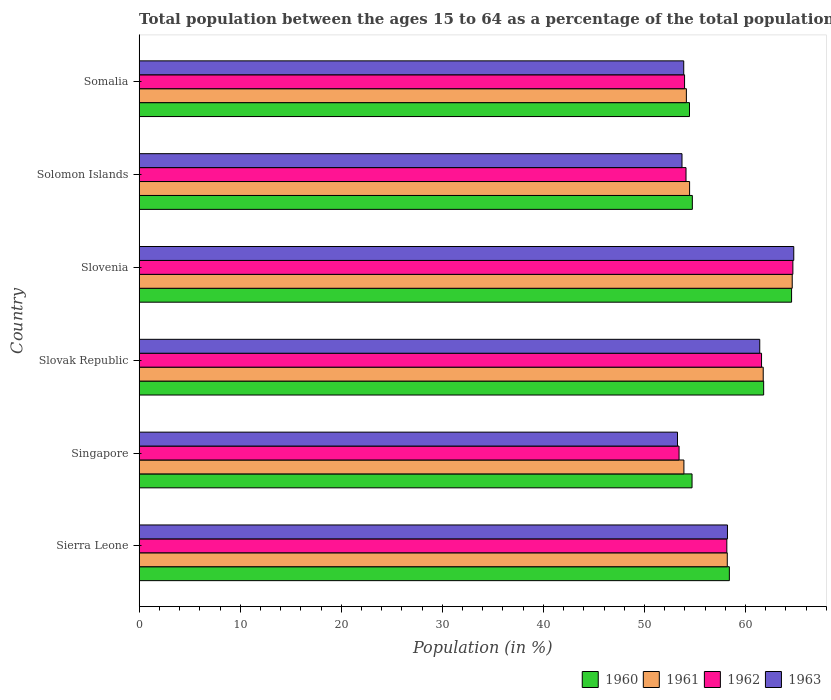How many different coloured bars are there?
Ensure brevity in your answer.  4. How many groups of bars are there?
Your answer should be very brief. 6. How many bars are there on the 4th tick from the top?
Your response must be concise. 4. What is the label of the 2nd group of bars from the top?
Make the answer very short. Solomon Islands. What is the percentage of the population ages 15 to 64 in 1960 in Sierra Leone?
Your answer should be very brief. 58.4. Across all countries, what is the maximum percentage of the population ages 15 to 64 in 1961?
Give a very brief answer. 64.62. Across all countries, what is the minimum percentage of the population ages 15 to 64 in 1960?
Your answer should be compact. 54.46. In which country was the percentage of the population ages 15 to 64 in 1961 maximum?
Offer a terse response. Slovenia. In which country was the percentage of the population ages 15 to 64 in 1960 minimum?
Your answer should be compact. Somalia. What is the total percentage of the population ages 15 to 64 in 1961 in the graph?
Ensure brevity in your answer.  347.1. What is the difference between the percentage of the population ages 15 to 64 in 1963 in Slovak Republic and that in Solomon Islands?
Your answer should be compact. 7.69. What is the difference between the percentage of the population ages 15 to 64 in 1960 in Slovenia and the percentage of the population ages 15 to 64 in 1962 in Singapore?
Make the answer very short. 11.14. What is the average percentage of the population ages 15 to 64 in 1963 per country?
Offer a terse response. 57.55. What is the difference between the percentage of the population ages 15 to 64 in 1960 and percentage of the population ages 15 to 64 in 1962 in Sierra Leone?
Your response must be concise. 0.25. In how many countries, is the percentage of the population ages 15 to 64 in 1962 greater than 58 ?
Your answer should be compact. 3. What is the ratio of the percentage of the population ages 15 to 64 in 1960 in Slovenia to that in Somalia?
Give a very brief answer. 1.19. What is the difference between the highest and the second highest percentage of the population ages 15 to 64 in 1960?
Provide a short and direct response. 2.76. What is the difference between the highest and the lowest percentage of the population ages 15 to 64 in 1960?
Your response must be concise. 10.1. What does the 2nd bar from the top in Slovenia represents?
Ensure brevity in your answer.  1962. Is it the case that in every country, the sum of the percentage of the population ages 15 to 64 in 1963 and percentage of the population ages 15 to 64 in 1961 is greater than the percentage of the population ages 15 to 64 in 1960?
Your response must be concise. Yes. Are all the bars in the graph horizontal?
Ensure brevity in your answer.  Yes. How many countries are there in the graph?
Keep it short and to the point. 6. Are the values on the major ticks of X-axis written in scientific E-notation?
Your answer should be very brief. No. Does the graph contain any zero values?
Make the answer very short. No. Does the graph contain grids?
Offer a very short reply. No. How many legend labels are there?
Ensure brevity in your answer.  4. How are the legend labels stacked?
Ensure brevity in your answer.  Horizontal. What is the title of the graph?
Make the answer very short. Total population between the ages 15 to 64 as a percentage of the total population. What is the label or title of the Y-axis?
Give a very brief answer. Country. What is the Population (in %) in 1960 in Sierra Leone?
Ensure brevity in your answer.  58.4. What is the Population (in %) in 1961 in Sierra Leone?
Offer a very short reply. 58.2. What is the Population (in %) of 1962 in Sierra Leone?
Give a very brief answer. 58.15. What is the Population (in %) of 1963 in Sierra Leone?
Your response must be concise. 58.21. What is the Population (in %) in 1960 in Singapore?
Provide a short and direct response. 54.71. What is the Population (in %) in 1961 in Singapore?
Your response must be concise. 53.91. What is the Population (in %) in 1962 in Singapore?
Your response must be concise. 53.42. What is the Population (in %) in 1963 in Singapore?
Provide a short and direct response. 53.27. What is the Population (in %) in 1960 in Slovak Republic?
Your response must be concise. 61.8. What is the Population (in %) in 1961 in Slovak Republic?
Ensure brevity in your answer.  61.75. What is the Population (in %) in 1962 in Slovak Republic?
Keep it short and to the point. 61.59. What is the Population (in %) of 1963 in Slovak Republic?
Give a very brief answer. 61.41. What is the Population (in %) in 1960 in Slovenia?
Your answer should be very brief. 64.56. What is the Population (in %) in 1961 in Slovenia?
Provide a succinct answer. 64.62. What is the Population (in %) in 1962 in Slovenia?
Ensure brevity in your answer.  64.69. What is the Population (in %) in 1963 in Slovenia?
Your answer should be compact. 64.78. What is the Population (in %) of 1960 in Solomon Islands?
Ensure brevity in your answer.  54.74. What is the Population (in %) of 1961 in Solomon Islands?
Keep it short and to the point. 54.47. What is the Population (in %) in 1962 in Solomon Islands?
Your response must be concise. 54.11. What is the Population (in %) in 1963 in Solomon Islands?
Your answer should be very brief. 53.72. What is the Population (in %) in 1960 in Somalia?
Your response must be concise. 54.46. What is the Population (in %) of 1961 in Somalia?
Provide a succinct answer. 54.15. What is the Population (in %) of 1962 in Somalia?
Give a very brief answer. 53.97. What is the Population (in %) in 1963 in Somalia?
Provide a short and direct response. 53.89. Across all countries, what is the maximum Population (in %) of 1960?
Offer a terse response. 64.56. Across all countries, what is the maximum Population (in %) in 1961?
Make the answer very short. 64.62. Across all countries, what is the maximum Population (in %) of 1962?
Offer a very short reply. 64.69. Across all countries, what is the maximum Population (in %) of 1963?
Offer a very short reply. 64.78. Across all countries, what is the minimum Population (in %) of 1960?
Provide a short and direct response. 54.46. Across all countries, what is the minimum Population (in %) in 1961?
Keep it short and to the point. 53.91. Across all countries, what is the minimum Population (in %) of 1962?
Keep it short and to the point. 53.42. Across all countries, what is the minimum Population (in %) of 1963?
Offer a terse response. 53.27. What is the total Population (in %) of 1960 in the graph?
Offer a terse response. 348.67. What is the total Population (in %) of 1961 in the graph?
Your answer should be compact. 347.1. What is the total Population (in %) of 1962 in the graph?
Your answer should be very brief. 345.94. What is the total Population (in %) in 1963 in the graph?
Provide a short and direct response. 345.28. What is the difference between the Population (in %) of 1960 in Sierra Leone and that in Singapore?
Offer a very short reply. 3.69. What is the difference between the Population (in %) of 1961 in Sierra Leone and that in Singapore?
Provide a succinct answer. 4.29. What is the difference between the Population (in %) of 1962 in Sierra Leone and that in Singapore?
Make the answer very short. 4.73. What is the difference between the Population (in %) of 1963 in Sierra Leone and that in Singapore?
Your response must be concise. 4.94. What is the difference between the Population (in %) of 1960 in Sierra Leone and that in Slovak Republic?
Give a very brief answer. -3.39. What is the difference between the Population (in %) in 1961 in Sierra Leone and that in Slovak Republic?
Offer a terse response. -3.56. What is the difference between the Population (in %) in 1962 in Sierra Leone and that in Slovak Republic?
Make the answer very short. -3.44. What is the difference between the Population (in %) in 1963 in Sierra Leone and that in Slovak Republic?
Offer a terse response. -3.19. What is the difference between the Population (in %) of 1960 in Sierra Leone and that in Slovenia?
Ensure brevity in your answer.  -6.16. What is the difference between the Population (in %) of 1961 in Sierra Leone and that in Slovenia?
Offer a terse response. -6.43. What is the difference between the Population (in %) of 1962 in Sierra Leone and that in Slovenia?
Give a very brief answer. -6.54. What is the difference between the Population (in %) of 1963 in Sierra Leone and that in Slovenia?
Keep it short and to the point. -6.56. What is the difference between the Population (in %) of 1960 in Sierra Leone and that in Solomon Islands?
Give a very brief answer. 3.66. What is the difference between the Population (in %) in 1961 in Sierra Leone and that in Solomon Islands?
Give a very brief answer. 3.73. What is the difference between the Population (in %) in 1962 in Sierra Leone and that in Solomon Islands?
Keep it short and to the point. 4.04. What is the difference between the Population (in %) in 1963 in Sierra Leone and that in Solomon Islands?
Your answer should be compact. 4.5. What is the difference between the Population (in %) in 1960 in Sierra Leone and that in Somalia?
Your answer should be very brief. 3.95. What is the difference between the Population (in %) of 1961 in Sierra Leone and that in Somalia?
Ensure brevity in your answer.  4.05. What is the difference between the Population (in %) of 1962 in Sierra Leone and that in Somalia?
Your answer should be very brief. 4.18. What is the difference between the Population (in %) of 1963 in Sierra Leone and that in Somalia?
Keep it short and to the point. 4.33. What is the difference between the Population (in %) in 1960 in Singapore and that in Slovak Republic?
Provide a short and direct response. -7.09. What is the difference between the Population (in %) of 1961 in Singapore and that in Slovak Republic?
Make the answer very short. -7.85. What is the difference between the Population (in %) of 1962 in Singapore and that in Slovak Republic?
Make the answer very short. -8.16. What is the difference between the Population (in %) of 1963 in Singapore and that in Slovak Republic?
Your answer should be compact. -8.14. What is the difference between the Population (in %) in 1960 in Singapore and that in Slovenia?
Provide a succinct answer. -9.85. What is the difference between the Population (in %) of 1961 in Singapore and that in Slovenia?
Ensure brevity in your answer.  -10.72. What is the difference between the Population (in %) of 1962 in Singapore and that in Slovenia?
Ensure brevity in your answer.  -11.26. What is the difference between the Population (in %) of 1963 in Singapore and that in Slovenia?
Give a very brief answer. -11.5. What is the difference between the Population (in %) of 1960 in Singapore and that in Solomon Islands?
Provide a short and direct response. -0.03. What is the difference between the Population (in %) of 1961 in Singapore and that in Solomon Islands?
Make the answer very short. -0.56. What is the difference between the Population (in %) in 1962 in Singapore and that in Solomon Islands?
Provide a succinct answer. -0.69. What is the difference between the Population (in %) of 1963 in Singapore and that in Solomon Islands?
Offer a terse response. -0.45. What is the difference between the Population (in %) of 1960 in Singapore and that in Somalia?
Provide a succinct answer. 0.25. What is the difference between the Population (in %) in 1961 in Singapore and that in Somalia?
Offer a very short reply. -0.24. What is the difference between the Population (in %) in 1962 in Singapore and that in Somalia?
Your answer should be compact. -0.54. What is the difference between the Population (in %) in 1963 in Singapore and that in Somalia?
Your answer should be compact. -0.62. What is the difference between the Population (in %) in 1960 in Slovak Republic and that in Slovenia?
Ensure brevity in your answer.  -2.76. What is the difference between the Population (in %) of 1961 in Slovak Republic and that in Slovenia?
Make the answer very short. -2.87. What is the difference between the Population (in %) in 1962 in Slovak Republic and that in Slovenia?
Provide a short and direct response. -3.1. What is the difference between the Population (in %) in 1963 in Slovak Republic and that in Slovenia?
Give a very brief answer. -3.37. What is the difference between the Population (in %) in 1960 in Slovak Republic and that in Solomon Islands?
Offer a terse response. 7.06. What is the difference between the Population (in %) of 1961 in Slovak Republic and that in Solomon Islands?
Your response must be concise. 7.29. What is the difference between the Population (in %) in 1962 in Slovak Republic and that in Solomon Islands?
Provide a succinct answer. 7.47. What is the difference between the Population (in %) of 1963 in Slovak Republic and that in Solomon Islands?
Provide a short and direct response. 7.69. What is the difference between the Population (in %) of 1960 in Slovak Republic and that in Somalia?
Make the answer very short. 7.34. What is the difference between the Population (in %) of 1961 in Slovak Republic and that in Somalia?
Your response must be concise. 7.6. What is the difference between the Population (in %) in 1962 in Slovak Republic and that in Somalia?
Your answer should be compact. 7.62. What is the difference between the Population (in %) of 1963 in Slovak Republic and that in Somalia?
Ensure brevity in your answer.  7.52. What is the difference between the Population (in %) of 1960 in Slovenia and that in Solomon Islands?
Provide a short and direct response. 9.82. What is the difference between the Population (in %) of 1961 in Slovenia and that in Solomon Islands?
Provide a short and direct response. 10.16. What is the difference between the Population (in %) of 1962 in Slovenia and that in Solomon Islands?
Keep it short and to the point. 10.57. What is the difference between the Population (in %) of 1963 in Slovenia and that in Solomon Islands?
Offer a terse response. 11.06. What is the difference between the Population (in %) of 1960 in Slovenia and that in Somalia?
Your answer should be compact. 10.1. What is the difference between the Population (in %) in 1961 in Slovenia and that in Somalia?
Keep it short and to the point. 10.47. What is the difference between the Population (in %) in 1962 in Slovenia and that in Somalia?
Ensure brevity in your answer.  10.72. What is the difference between the Population (in %) of 1963 in Slovenia and that in Somalia?
Your answer should be compact. 10.89. What is the difference between the Population (in %) of 1960 in Solomon Islands and that in Somalia?
Provide a succinct answer. 0.28. What is the difference between the Population (in %) in 1961 in Solomon Islands and that in Somalia?
Provide a succinct answer. 0.32. What is the difference between the Population (in %) in 1962 in Solomon Islands and that in Somalia?
Ensure brevity in your answer.  0.14. What is the difference between the Population (in %) in 1963 in Solomon Islands and that in Somalia?
Offer a very short reply. -0.17. What is the difference between the Population (in %) in 1960 in Sierra Leone and the Population (in %) in 1961 in Singapore?
Keep it short and to the point. 4.5. What is the difference between the Population (in %) of 1960 in Sierra Leone and the Population (in %) of 1962 in Singapore?
Offer a terse response. 4.98. What is the difference between the Population (in %) in 1960 in Sierra Leone and the Population (in %) in 1963 in Singapore?
Offer a terse response. 5.13. What is the difference between the Population (in %) in 1961 in Sierra Leone and the Population (in %) in 1962 in Singapore?
Ensure brevity in your answer.  4.77. What is the difference between the Population (in %) in 1961 in Sierra Leone and the Population (in %) in 1963 in Singapore?
Your response must be concise. 4.93. What is the difference between the Population (in %) of 1962 in Sierra Leone and the Population (in %) of 1963 in Singapore?
Offer a very short reply. 4.88. What is the difference between the Population (in %) of 1960 in Sierra Leone and the Population (in %) of 1961 in Slovak Republic?
Give a very brief answer. -3.35. What is the difference between the Population (in %) in 1960 in Sierra Leone and the Population (in %) in 1962 in Slovak Republic?
Your response must be concise. -3.18. What is the difference between the Population (in %) of 1960 in Sierra Leone and the Population (in %) of 1963 in Slovak Republic?
Offer a terse response. -3.01. What is the difference between the Population (in %) in 1961 in Sierra Leone and the Population (in %) in 1962 in Slovak Republic?
Provide a succinct answer. -3.39. What is the difference between the Population (in %) in 1961 in Sierra Leone and the Population (in %) in 1963 in Slovak Republic?
Your response must be concise. -3.21. What is the difference between the Population (in %) in 1962 in Sierra Leone and the Population (in %) in 1963 in Slovak Republic?
Give a very brief answer. -3.26. What is the difference between the Population (in %) in 1960 in Sierra Leone and the Population (in %) in 1961 in Slovenia?
Keep it short and to the point. -6.22. What is the difference between the Population (in %) in 1960 in Sierra Leone and the Population (in %) in 1962 in Slovenia?
Your answer should be very brief. -6.29. What is the difference between the Population (in %) of 1960 in Sierra Leone and the Population (in %) of 1963 in Slovenia?
Make the answer very short. -6.37. What is the difference between the Population (in %) in 1961 in Sierra Leone and the Population (in %) in 1962 in Slovenia?
Offer a terse response. -6.49. What is the difference between the Population (in %) in 1961 in Sierra Leone and the Population (in %) in 1963 in Slovenia?
Your response must be concise. -6.58. What is the difference between the Population (in %) in 1962 in Sierra Leone and the Population (in %) in 1963 in Slovenia?
Keep it short and to the point. -6.62. What is the difference between the Population (in %) of 1960 in Sierra Leone and the Population (in %) of 1961 in Solomon Islands?
Make the answer very short. 3.93. What is the difference between the Population (in %) of 1960 in Sierra Leone and the Population (in %) of 1962 in Solomon Islands?
Offer a very short reply. 4.29. What is the difference between the Population (in %) in 1960 in Sierra Leone and the Population (in %) in 1963 in Solomon Islands?
Keep it short and to the point. 4.69. What is the difference between the Population (in %) of 1961 in Sierra Leone and the Population (in %) of 1962 in Solomon Islands?
Keep it short and to the point. 4.08. What is the difference between the Population (in %) in 1961 in Sierra Leone and the Population (in %) in 1963 in Solomon Islands?
Your answer should be very brief. 4.48. What is the difference between the Population (in %) of 1962 in Sierra Leone and the Population (in %) of 1963 in Solomon Islands?
Offer a very short reply. 4.44. What is the difference between the Population (in %) of 1960 in Sierra Leone and the Population (in %) of 1961 in Somalia?
Make the answer very short. 4.25. What is the difference between the Population (in %) in 1960 in Sierra Leone and the Population (in %) in 1962 in Somalia?
Your response must be concise. 4.43. What is the difference between the Population (in %) in 1960 in Sierra Leone and the Population (in %) in 1963 in Somalia?
Your answer should be very brief. 4.52. What is the difference between the Population (in %) of 1961 in Sierra Leone and the Population (in %) of 1962 in Somalia?
Your answer should be very brief. 4.23. What is the difference between the Population (in %) of 1961 in Sierra Leone and the Population (in %) of 1963 in Somalia?
Offer a terse response. 4.31. What is the difference between the Population (in %) of 1962 in Sierra Leone and the Population (in %) of 1963 in Somalia?
Your answer should be very brief. 4.26. What is the difference between the Population (in %) in 1960 in Singapore and the Population (in %) in 1961 in Slovak Republic?
Keep it short and to the point. -7.04. What is the difference between the Population (in %) in 1960 in Singapore and the Population (in %) in 1962 in Slovak Republic?
Your response must be concise. -6.88. What is the difference between the Population (in %) in 1960 in Singapore and the Population (in %) in 1963 in Slovak Republic?
Your response must be concise. -6.7. What is the difference between the Population (in %) of 1961 in Singapore and the Population (in %) of 1962 in Slovak Republic?
Your answer should be very brief. -7.68. What is the difference between the Population (in %) in 1961 in Singapore and the Population (in %) in 1963 in Slovak Republic?
Your answer should be compact. -7.5. What is the difference between the Population (in %) in 1962 in Singapore and the Population (in %) in 1963 in Slovak Republic?
Provide a succinct answer. -7.98. What is the difference between the Population (in %) of 1960 in Singapore and the Population (in %) of 1961 in Slovenia?
Your response must be concise. -9.91. What is the difference between the Population (in %) in 1960 in Singapore and the Population (in %) in 1962 in Slovenia?
Provide a short and direct response. -9.98. What is the difference between the Population (in %) of 1960 in Singapore and the Population (in %) of 1963 in Slovenia?
Your response must be concise. -10.06. What is the difference between the Population (in %) of 1961 in Singapore and the Population (in %) of 1962 in Slovenia?
Your answer should be compact. -10.78. What is the difference between the Population (in %) in 1961 in Singapore and the Population (in %) in 1963 in Slovenia?
Your response must be concise. -10.87. What is the difference between the Population (in %) of 1962 in Singapore and the Population (in %) of 1963 in Slovenia?
Keep it short and to the point. -11.35. What is the difference between the Population (in %) of 1960 in Singapore and the Population (in %) of 1961 in Solomon Islands?
Your response must be concise. 0.24. What is the difference between the Population (in %) in 1960 in Singapore and the Population (in %) in 1962 in Solomon Islands?
Your answer should be very brief. 0.6. What is the difference between the Population (in %) of 1961 in Singapore and the Population (in %) of 1962 in Solomon Islands?
Keep it short and to the point. -0.21. What is the difference between the Population (in %) in 1961 in Singapore and the Population (in %) in 1963 in Solomon Islands?
Your answer should be compact. 0.19. What is the difference between the Population (in %) of 1962 in Singapore and the Population (in %) of 1963 in Solomon Islands?
Keep it short and to the point. -0.29. What is the difference between the Population (in %) of 1960 in Singapore and the Population (in %) of 1961 in Somalia?
Provide a short and direct response. 0.56. What is the difference between the Population (in %) in 1960 in Singapore and the Population (in %) in 1962 in Somalia?
Your answer should be compact. 0.74. What is the difference between the Population (in %) of 1960 in Singapore and the Population (in %) of 1963 in Somalia?
Your answer should be very brief. 0.82. What is the difference between the Population (in %) in 1961 in Singapore and the Population (in %) in 1962 in Somalia?
Your answer should be very brief. -0.06. What is the difference between the Population (in %) in 1961 in Singapore and the Population (in %) in 1963 in Somalia?
Give a very brief answer. 0.02. What is the difference between the Population (in %) in 1962 in Singapore and the Population (in %) in 1963 in Somalia?
Offer a very short reply. -0.46. What is the difference between the Population (in %) in 1960 in Slovak Republic and the Population (in %) in 1961 in Slovenia?
Make the answer very short. -2.83. What is the difference between the Population (in %) of 1960 in Slovak Republic and the Population (in %) of 1962 in Slovenia?
Offer a very short reply. -2.89. What is the difference between the Population (in %) in 1960 in Slovak Republic and the Population (in %) in 1963 in Slovenia?
Offer a very short reply. -2.98. What is the difference between the Population (in %) in 1961 in Slovak Republic and the Population (in %) in 1962 in Slovenia?
Your answer should be compact. -2.93. What is the difference between the Population (in %) in 1961 in Slovak Republic and the Population (in %) in 1963 in Slovenia?
Your answer should be compact. -3.02. What is the difference between the Population (in %) of 1962 in Slovak Republic and the Population (in %) of 1963 in Slovenia?
Provide a short and direct response. -3.19. What is the difference between the Population (in %) in 1960 in Slovak Republic and the Population (in %) in 1961 in Solomon Islands?
Provide a short and direct response. 7.33. What is the difference between the Population (in %) in 1960 in Slovak Republic and the Population (in %) in 1962 in Solomon Islands?
Your response must be concise. 7.68. What is the difference between the Population (in %) in 1960 in Slovak Republic and the Population (in %) in 1963 in Solomon Islands?
Make the answer very short. 8.08. What is the difference between the Population (in %) in 1961 in Slovak Republic and the Population (in %) in 1962 in Solomon Islands?
Give a very brief answer. 7.64. What is the difference between the Population (in %) in 1961 in Slovak Republic and the Population (in %) in 1963 in Solomon Islands?
Your answer should be compact. 8.04. What is the difference between the Population (in %) in 1962 in Slovak Republic and the Population (in %) in 1963 in Solomon Islands?
Your response must be concise. 7.87. What is the difference between the Population (in %) of 1960 in Slovak Republic and the Population (in %) of 1961 in Somalia?
Your answer should be compact. 7.65. What is the difference between the Population (in %) in 1960 in Slovak Republic and the Population (in %) in 1962 in Somalia?
Your response must be concise. 7.83. What is the difference between the Population (in %) in 1960 in Slovak Republic and the Population (in %) in 1963 in Somalia?
Your answer should be compact. 7.91. What is the difference between the Population (in %) in 1961 in Slovak Republic and the Population (in %) in 1962 in Somalia?
Your answer should be compact. 7.78. What is the difference between the Population (in %) in 1961 in Slovak Republic and the Population (in %) in 1963 in Somalia?
Make the answer very short. 7.87. What is the difference between the Population (in %) of 1962 in Slovak Republic and the Population (in %) of 1963 in Somalia?
Give a very brief answer. 7.7. What is the difference between the Population (in %) of 1960 in Slovenia and the Population (in %) of 1961 in Solomon Islands?
Your response must be concise. 10.09. What is the difference between the Population (in %) of 1960 in Slovenia and the Population (in %) of 1962 in Solomon Islands?
Make the answer very short. 10.45. What is the difference between the Population (in %) of 1960 in Slovenia and the Population (in %) of 1963 in Solomon Islands?
Keep it short and to the point. 10.84. What is the difference between the Population (in %) of 1961 in Slovenia and the Population (in %) of 1962 in Solomon Islands?
Offer a terse response. 10.51. What is the difference between the Population (in %) in 1961 in Slovenia and the Population (in %) in 1963 in Solomon Islands?
Provide a short and direct response. 10.91. What is the difference between the Population (in %) of 1962 in Slovenia and the Population (in %) of 1963 in Solomon Islands?
Provide a short and direct response. 10.97. What is the difference between the Population (in %) of 1960 in Slovenia and the Population (in %) of 1961 in Somalia?
Provide a short and direct response. 10.41. What is the difference between the Population (in %) in 1960 in Slovenia and the Population (in %) in 1962 in Somalia?
Offer a terse response. 10.59. What is the difference between the Population (in %) in 1960 in Slovenia and the Population (in %) in 1963 in Somalia?
Keep it short and to the point. 10.67. What is the difference between the Population (in %) in 1961 in Slovenia and the Population (in %) in 1962 in Somalia?
Your answer should be compact. 10.65. What is the difference between the Population (in %) of 1961 in Slovenia and the Population (in %) of 1963 in Somalia?
Make the answer very short. 10.74. What is the difference between the Population (in %) of 1962 in Slovenia and the Population (in %) of 1963 in Somalia?
Your response must be concise. 10.8. What is the difference between the Population (in %) of 1960 in Solomon Islands and the Population (in %) of 1961 in Somalia?
Offer a very short reply. 0.59. What is the difference between the Population (in %) of 1960 in Solomon Islands and the Population (in %) of 1962 in Somalia?
Your answer should be very brief. 0.77. What is the difference between the Population (in %) in 1960 in Solomon Islands and the Population (in %) in 1963 in Somalia?
Your answer should be very brief. 0.85. What is the difference between the Population (in %) of 1961 in Solomon Islands and the Population (in %) of 1962 in Somalia?
Your response must be concise. 0.5. What is the difference between the Population (in %) of 1961 in Solomon Islands and the Population (in %) of 1963 in Somalia?
Provide a short and direct response. 0.58. What is the difference between the Population (in %) in 1962 in Solomon Islands and the Population (in %) in 1963 in Somalia?
Ensure brevity in your answer.  0.23. What is the average Population (in %) of 1960 per country?
Offer a terse response. 58.11. What is the average Population (in %) of 1961 per country?
Give a very brief answer. 57.85. What is the average Population (in %) of 1962 per country?
Offer a terse response. 57.66. What is the average Population (in %) in 1963 per country?
Make the answer very short. 57.55. What is the difference between the Population (in %) in 1960 and Population (in %) in 1961 in Sierra Leone?
Keep it short and to the point. 0.21. What is the difference between the Population (in %) in 1960 and Population (in %) in 1962 in Sierra Leone?
Give a very brief answer. 0.25. What is the difference between the Population (in %) of 1960 and Population (in %) of 1963 in Sierra Leone?
Provide a short and direct response. 0.19. What is the difference between the Population (in %) of 1961 and Population (in %) of 1962 in Sierra Leone?
Give a very brief answer. 0.05. What is the difference between the Population (in %) in 1961 and Population (in %) in 1963 in Sierra Leone?
Ensure brevity in your answer.  -0.02. What is the difference between the Population (in %) of 1962 and Population (in %) of 1963 in Sierra Leone?
Your answer should be very brief. -0.06. What is the difference between the Population (in %) in 1960 and Population (in %) in 1961 in Singapore?
Your response must be concise. 0.81. What is the difference between the Population (in %) in 1960 and Population (in %) in 1962 in Singapore?
Ensure brevity in your answer.  1.29. What is the difference between the Population (in %) of 1960 and Population (in %) of 1963 in Singapore?
Your response must be concise. 1.44. What is the difference between the Population (in %) in 1961 and Population (in %) in 1962 in Singapore?
Your response must be concise. 0.48. What is the difference between the Population (in %) in 1961 and Population (in %) in 1963 in Singapore?
Ensure brevity in your answer.  0.63. What is the difference between the Population (in %) of 1962 and Population (in %) of 1963 in Singapore?
Your answer should be very brief. 0.15. What is the difference between the Population (in %) in 1960 and Population (in %) in 1961 in Slovak Republic?
Ensure brevity in your answer.  0.04. What is the difference between the Population (in %) of 1960 and Population (in %) of 1962 in Slovak Republic?
Your response must be concise. 0.21. What is the difference between the Population (in %) of 1960 and Population (in %) of 1963 in Slovak Republic?
Your response must be concise. 0.39. What is the difference between the Population (in %) in 1961 and Population (in %) in 1962 in Slovak Republic?
Provide a succinct answer. 0.17. What is the difference between the Population (in %) of 1961 and Population (in %) of 1963 in Slovak Republic?
Offer a very short reply. 0.34. What is the difference between the Population (in %) of 1962 and Population (in %) of 1963 in Slovak Republic?
Offer a terse response. 0.18. What is the difference between the Population (in %) in 1960 and Population (in %) in 1961 in Slovenia?
Give a very brief answer. -0.06. What is the difference between the Population (in %) of 1960 and Population (in %) of 1962 in Slovenia?
Ensure brevity in your answer.  -0.13. What is the difference between the Population (in %) of 1960 and Population (in %) of 1963 in Slovenia?
Provide a succinct answer. -0.22. What is the difference between the Population (in %) in 1961 and Population (in %) in 1962 in Slovenia?
Give a very brief answer. -0.06. What is the difference between the Population (in %) in 1961 and Population (in %) in 1963 in Slovenia?
Your response must be concise. -0.15. What is the difference between the Population (in %) in 1962 and Population (in %) in 1963 in Slovenia?
Your answer should be compact. -0.09. What is the difference between the Population (in %) in 1960 and Population (in %) in 1961 in Solomon Islands?
Your response must be concise. 0.27. What is the difference between the Population (in %) of 1960 and Population (in %) of 1962 in Solomon Islands?
Your answer should be compact. 0.63. What is the difference between the Population (in %) of 1960 and Population (in %) of 1963 in Solomon Islands?
Make the answer very short. 1.02. What is the difference between the Population (in %) in 1961 and Population (in %) in 1962 in Solomon Islands?
Provide a short and direct response. 0.35. What is the difference between the Population (in %) in 1961 and Population (in %) in 1963 in Solomon Islands?
Offer a terse response. 0.75. What is the difference between the Population (in %) in 1962 and Population (in %) in 1963 in Solomon Islands?
Provide a succinct answer. 0.4. What is the difference between the Population (in %) of 1960 and Population (in %) of 1961 in Somalia?
Make the answer very short. 0.31. What is the difference between the Population (in %) of 1960 and Population (in %) of 1962 in Somalia?
Give a very brief answer. 0.49. What is the difference between the Population (in %) of 1960 and Population (in %) of 1963 in Somalia?
Provide a short and direct response. 0.57. What is the difference between the Population (in %) of 1961 and Population (in %) of 1962 in Somalia?
Your answer should be very brief. 0.18. What is the difference between the Population (in %) in 1961 and Population (in %) in 1963 in Somalia?
Provide a short and direct response. 0.26. What is the difference between the Population (in %) of 1962 and Population (in %) of 1963 in Somalia?
Offer a very short reply. 0.08. What is the ratio of the Population (in %) of 1960 in Sierra Leone to that in Singapore?
Your answer should be very brief. 1.07. What is the ratio of the Population (in %) in 1961 in Sierra Leone to that in Singapore?
Provide a succinct answer. 1.08. What is the ratio of the Population (in %) in 1962 in Sierra Leone to that in Singapore?
Your response must be concise. 1.09. What is the ratio of the Population (in %) in 1963 in Sierra Leone to that in Singapore?
Ensure brevity in your answer.  1.09. What is the ratio of the Population (in %) in 1960 in Sierra Leone to that in Slovak Republic?
Your response must be concise. 0.95. What is the ratio of the Population (in %) of 1961 in Sierra Leone to that in Slovak Republic?
Provide a succinct answer. 0.94. What is the ratio of the Population (in %) of 1962 in Sierra Leone to that in Slovak Republic?
Give a very brief answer. 0.94. What is the ratio of the Population (in %) of 1963 in Sierra Leone to that in Slovak Republic?
Offer a terse response. 0.95. What is the ratio of the Population (in %) of 1960 in Sierra Leone to that in Slovenia?
Give a very brief answer. 0.9. What is the ratio of the Population (in %) in 1961 in Sierra Leone to that in Slovenia?
Your answer should be compact. 0.9. What is the ratio of the Population (in %) of 1962 in Sierra Leone to that in Slovenia?
Provide a succinct answer. 0.9. What is the ratio of the Population (in %) of 1963 in Sierra Leone to that in Slovenia?
Your answer should be very brief. 0.9. What is the ratio of the Population (in %) of 1960 in Sierra Leone to that in Solomon Islands?
Your answer should be very brief. 1.07. What is the ratio of the Population (in %) of 1961 in Sierra Leone to that in Solomon Islands?
Keep it short and to the point. 1.07. What is the ratio of the Population (in %) in 1962 in Sierra Leone to that in Solomon Islands?
Give a very brief answer. 1.07. What is the ratio of the Population (in %) in 1963 in Sierra Leone to that in Solomon Islands?
Your answer should be very brief. 1.08. What is the ratio of the Population (in %) in 1960 in Sierra Leone to that in Somalia?
Your answer should be compact. 1.07. What is the ratio of the Population (in %) of 1961 in Sierra Leone to that in Somalia?
Your response must be concise. 1.07. What is the ratio of the Population (in %) in 1962 in Sierra Leone to that in Somalia?
Offer a terse response. 1.08. What is the ratio of the Population (in %) of 1963 in Sierra Leone to that in Somalia?
Provide a succinct answer. 1.08. What is the ratio of the Population (in %) of 1960 in Singapore to that in Slovak Republic?
Keep it short and to the point. 0.89. What is the ratio of the Population (in %) in 1961 in Singapore to that in Slovak Republic?
Offer a very short reply. 0.87. What is the ratio of the Population (in %) of 1962 in Singapore to that in Slovak Republic?
Your response must be concise. 0.87. What is the ratio of the Population (in %) in 1963 in Singapore to that in Slovak Republic?
Provide a short and direct response. 0.87. What is the ratio of the Population (in %) of 1960 in Singapore to that in Slovenia?
Give a very brief answer. 0.85. What is the ratio of the Population (in %) of 1961 in Singapore to that in Slovenia?
Ensure brevity in your answer.  0.83. What is the ratio of the Population (in %) in 1962 in Singapore to that in Slovenia?
Provide a succinct answer. 0.83. What is the ratio of the Population (in %) in 1963 in Singapore to that in Slovenia?
Provide a short and direct response. 0.82. What is the ratio of the Population (in %) in 1962 in Singapore to that in Solomon Islands?
Provide a succinct answer. 0.99. What is the ratio of the Population (in %) of 1963 in Singapore to that in Solomon Islands?
Offer a very short reply. 0.99. What is the ratio of the Population (in %) of 1961 in Singapore to that in Somalia?
Provide a short and direct response. 1. What is the ratio of the Population (in %) of 1960 in Slovak Republic to that in Slovenia?
Offer a very short reply. 0.96. What is the ratio of the Population (in %) in 1961 in Slovak Republic to that in Slovenia?
Offer a very short reply. 0.96. What is the ratio of the Population (in %) of 1962 in Slovak Republic to that in Slovenia?
Your response must be concise. 0.95. What is the ratio of the Population (in %) of 1963 in Slovak Republic to that in Slovenia?
Make the answer very short. 0.95. What is the ratio of the Population (in %) of 1960 in Slovak Republic to that in Solomon Islands?
Your answer should be compact. 1.13. What is the ratio of the Population (in %) in 1961 in Slovak Republic to that in Solomon Islands?
Keep it short and to the point. 1.13. What is the ratio of the Population (in %) of 1962 in Slovak Republic to that in Solomon Islands?
Your answer should be compact. 1.14. What is the ratio of the Population (in %) of 1963 in Slovak Republic to that in Solomon Islands?
Provide a succinct answer. 1.14. What is the ratio of the Population (in %) of 1960 in Slovak Republic to that in Somalia?
Offer a terse response. 1.13. What is the ratio of the Population (in %) in 1961 in Slovak Republic to that in Somalia?
Your response must be concise. 1.14. What is the ratio of the Population (in %) in 1962 in Slovak Republic to that in Somalia?
Offer a terse response. 1.14. What is the ratio of the Population (in %) of 1963 in Slovak Republic to that in Somalia?
Your response must be concise. 1.14. What is the ratio of the Population (in %) in 1960 in Slovenia to that in Solomon Islands?
Offer a very short reply. 1.18. What is the ratio of the Population (in %) in 1961 in Slovenia to that in Solomon Islands?
Provide a short and direct response. 1.19. What is the ratio of the Population (in %) of 1962 in Slovenia to that in Solomon Islands?
Provide a short and direct response. 1.2. What is the ratio of the Population (in %) of 1963 in Slovenia to that in Solomon Islands?
Ensure brevity in your answer.  1.21. What is the ratio of the Population (in %) in 1960 in Slovenia to that in Somalia?
Offer a very short reply. 1.19. What is the ratio of the Population (in %) in 1961 in Slovenia to that in Somalia?
Provide a succinct answer. 1.19. What is the ratio of the Population (in %) in 1962 in Slovenia to that in Somalia?
Keep it short and to the point. 1.2. What is the ratio of the Population (in %) in 1963 in Slovenia to that in Somalia?
Give a very brief answer. 1.2. What is the ratio of the Population (in %) in 1961 in Solomon Islands to that in Somalia?
Give a very brief answer. 1.01. What is the difference between the highest and the second highest Population (in %) of 1960?
Your response must be concise. 2.76. What is the difference between the highest and the second highest Population (in %) in 1961?
Make the answer very short. 2.87. What is the difference between the highest and the second highest Population (in %) of 1962?
Offer a terse response. 3.1. What is the difference between the highest and the second highest Population (in %) in 1963?
Provide a short and direct response. 3.37. What is the difference between the highest and the lowest Population (in %) in 1960?
Keep it short and to the point. 10.1. What is the difference between the highest and the lowest Population (in %) of 1961?
Your response must be concise. 10.72. What is the difference between the highest and the lowest Population (in %) in 1962?
Provide a succinct answer. 11.26. What is the difference between the highest and the lowest Population (in %) in 1963?
Keep it short and to the point. 11.5. 